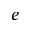Convert formula to latex. <formula><loc_0><loc_0><loc_500><loc_500>e</formula> 